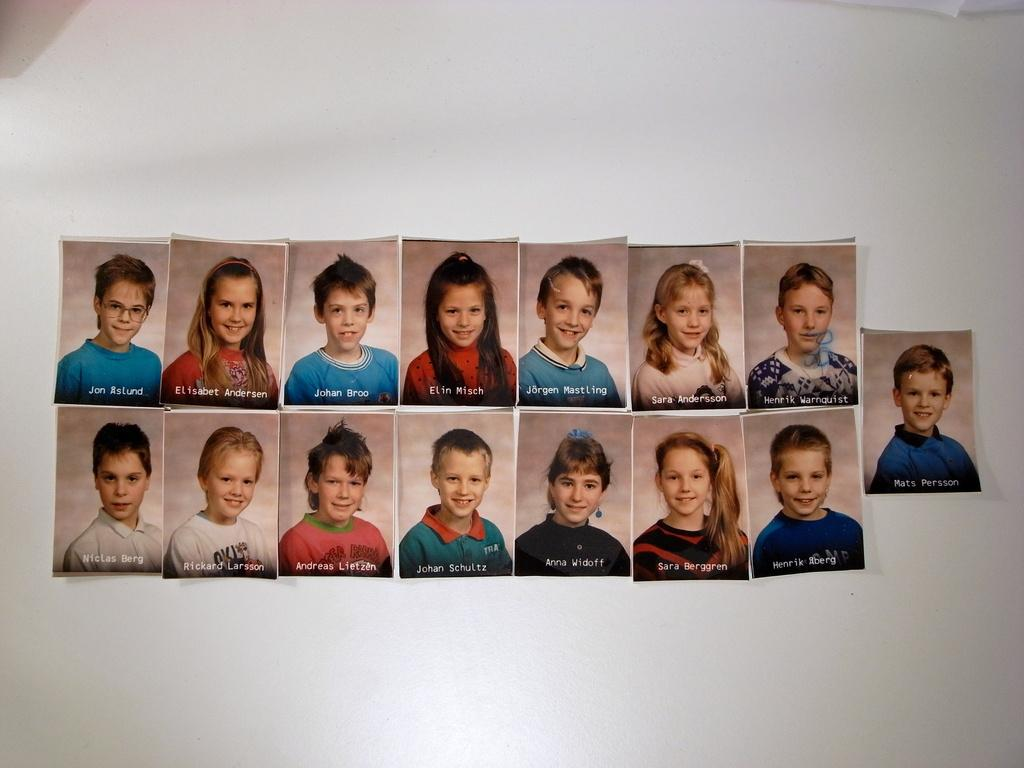What is depicted in the images on the wall? There are photographs of kids in the image. Where are the photographs located? The photographs are stuck on a wall. What additional information is provided with each photograph? Each photograph has text at the bottom. What type of air can be seen in the image? There is no air visible in the image; the focus is on the photographs of kids. 